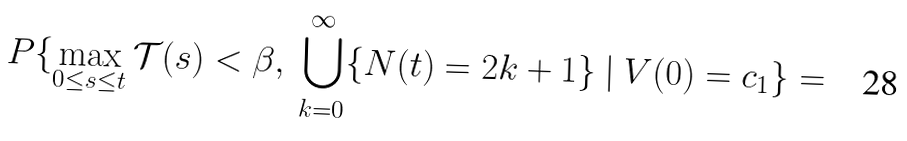<formula> <loc_0><loc_0><loc_500><loc_500>P \{ \max _ { 0 \leq s \leq t } \mathcal { T } ( s ) < \beta , \ \bigcup _ { k = 0 } ^ { \infty } \{ N ( t ) = 2 k + 1 \} \ | \ V ( 0 ) = c _ { 1 } \} =</formula> 